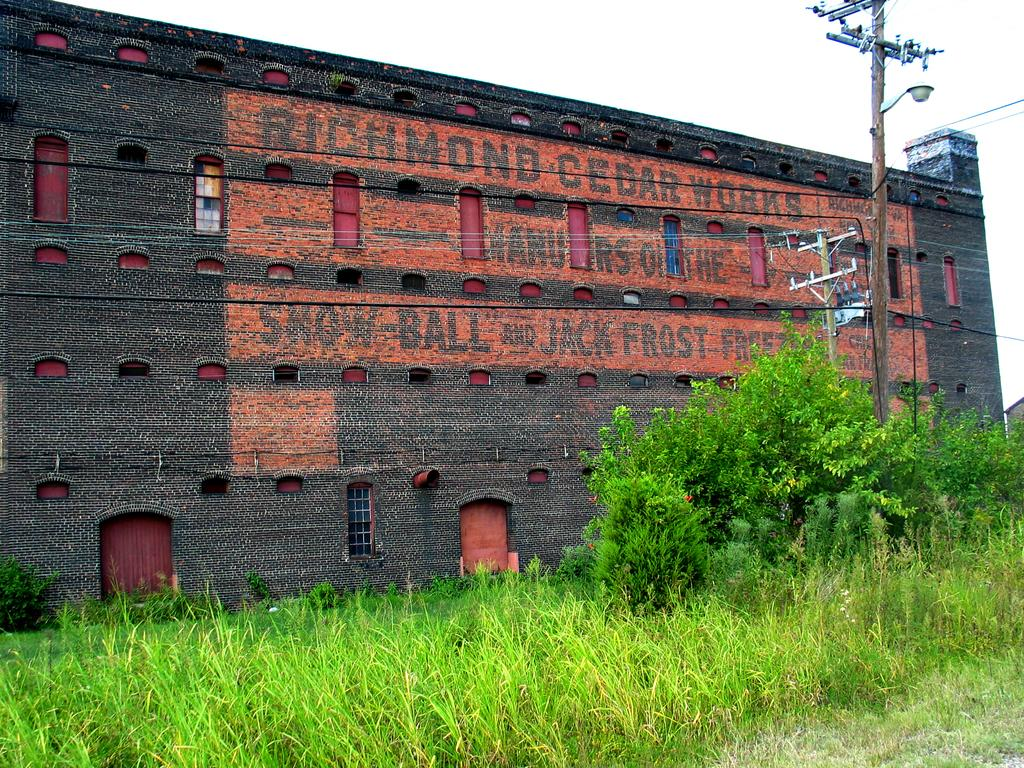What type of structure is visible in the image? There is a building in the image. What decorative element can be seen on the wall of the building? There is a painting on the wall in the image. What type of vegetation is present at the bottom of the image? Small plants and grass are present at the bottom of the image. What type of infrastructure can be seen on the right side of the image? There are electric poles on the right side of the image. What type of cemetery can be seen in the image? There is no cemetery present in the image. What type of mist is covering the building in the image? There is no mist present in the image; the building is clearly visible. 